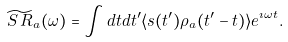Convert formula to latex. <formula><loc_0><loc_0><loc_500><loc_500>\widetilde { S \, R } _ { a } ( \omega ) = \int d t d t ^ { \prime } \langle s ( t ^ { \prime } ) \rho _ { a } ( t ^ { \prime } - t ) \rangle e ^ { \imath \omega t } .</formula> 